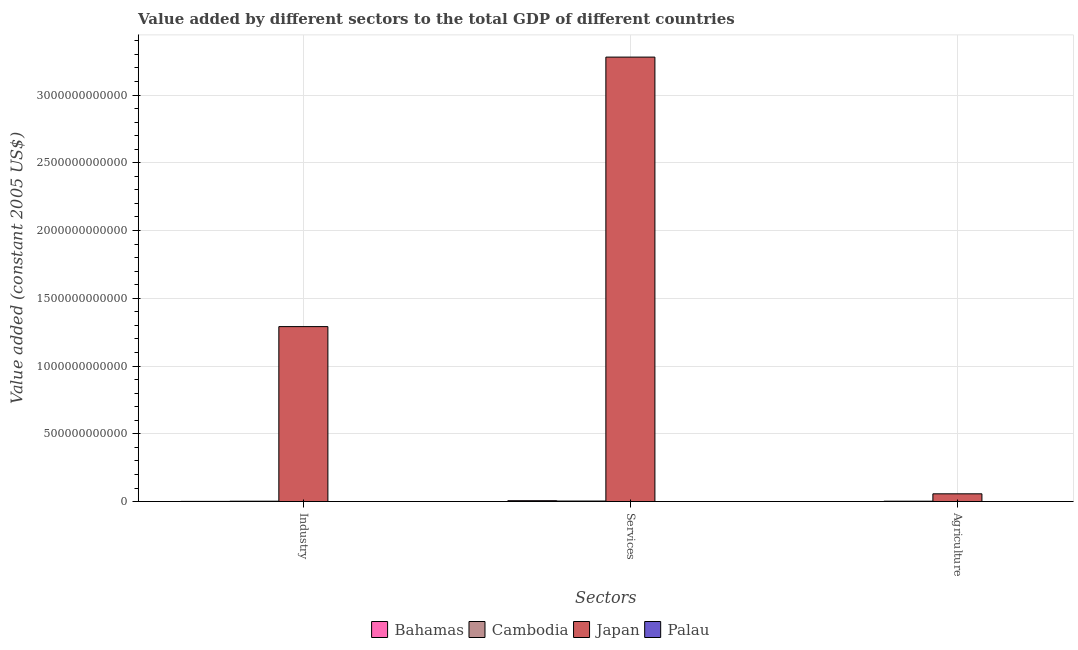How many groups of bars are there?
Keep it short and to the point. 3. Are the number of bars per tick equal to the number of legend labels?
Provide a succinct answer. Yes. Are the number of bars on each tick of the X-axis equal?
Give a very brief answer. Yes. What is the label of the 2nd group of bars from the left?
Your answer should be very brief. Services. What is the value added by agricultural sector in Palau?
Give a very brief answer. 7.39e+06. Across all countries, what is the maximum value added by industrial sector?
Your answer should be compact. 1.29e+12. Across all countries, what is the minimum value added by agricultural sector?
Offer a terse response. 7.39e+06. In which country was the value added by agricultural sector maximum?
Keep it short and to the point. Japan. In which country was the value added by industrial sector minimum?
Make the answer very short. Palau. What is the total value added by agricultural sector in the graph?
Your answer should be very brief. 6.00e+1. What is the difference between the value added by agricultural sector in Cambodia and that in Palau?
Provide a succinct answer. 2.66e+09. What is the difference between the value added by services in Palau and the value added by agricultural sector in Cambodia?
Your answer should be very brief. -2.52e+09. What is the average value added by industrial sector per country?
Ensure brevity in your answer.  3.24e+11. What is the difference between the value added by agricultural sector and value added by industrial sector in Japan?
Offer a very short reply. -1.23e+12. What is the ratio of the value added by agricultural sector in Japan to that in Cambodia?
Offer a terse response. 21.42. Is the difference between the value added by services in Japan and Cambodia greater than the difference between the value added by agricultural sector in Japan and Cambodia?
Your response must be concise. Yes. What is the difference between the highest and the second highest value added by agricultural sector?
Offer a terse response. 5.45e+1. What is the difference between the highest and the lowest value added by services?
Your answer should be compact. 3.28e+12. What does the 2nd bar from the left in Agriculture represents?
Provide a short and direct response. Cambodia. What does the 4th bar from the right in Agriculture represents?
Give a very brief answer. Bahamas. How many bars are there?
Your answer should be very brief. 12. How many countries are there in the graph?
Offer a terse response. 4. What is the difference between two consecutive major ticks on the Y-axis?
Offer a terse response. 5.00e+11. Does the graph contain any zero values?
Provide a short and direct response. No. Does the graph contain grids?
Your answer should be compact. Yes. How are the legend labels stacked?
Ensure brevity in your answer.  Horizontal. What is the title of the graph?
Offer a very short reply. Value added by different sectors to the total GDP of different countries. What is the label or title of the X-axis?
Offer a terse response. Sectors. What is the label or title of the Y-axis?
Ensure brevity in your answer.  Value added (constant 2005 US$). What is the Value added (constant 2005 US$) of Bahamas in Industry?
Keep it short and to the point. 1.32e+09. What is the Value added (constant 2005 US$) of Cambodia in Industry?
Provide a succinct answer. 2.70e+09. What is the Value added (constant 2005 US$) in Japan in Industry?
Ensure brevity in your answer.  1.29e+12. What is the Value added (constant 2005 US$) in Palau in Industry?
Your answer should be compact. 1.29e+07. What is the Value added (constant 2005 US$) in Bahamas in Services?
Offer a very short reply. 6.39e+09. What is the Value added (constant 2005 US$) of Cambodia in Services?
Provide a short and direct response. 3.90e+09. What is the Value added (constant 2005 US$) in Japan in Services?
Keep it short and to the point. 3.28e+12. What is the Value added (constant 2005 US$) in Palau in Services?
Make the answer very short. 1.47e+08. What is the Value added (constant 2005 US$) in Bahamas in Agriculture?
Your answer should be compact. 1.43e+08. What is the Value added (constant 2005 US$) of Cambodia in Agriculture?
Offer a very short reply. 2.67e+09. What is the Value added (constant 2005 US$) in Japan in Agriculture?
Give a very brief answer. 5.71e+1. What is the Value added (constant 2005 US$) in Palau in Agriculture?
Offer a very short reply. 7.39e+06. Across all Sectors, what is the maximum Value added (constant 2005 US$) in Bahamas?
Your response must be concise. 6.39e+09. Across all Sectors, what is the maximum Value added (constant 2005 US$) of Cambodia?
Offer a terse response. 3.90e+09. Across all Sectors, what is the maximum Value added (constant 2005 US$) in Japan?
Provide a succinct answer. 3.28e+12. Across all Sectors, what is the maximum Value added (constant 2005 US$) of Palau?
Your answer should be compact. 1.47e+08. Across all Sectors, what is the minimum Value added (constant 2005 US$) in Bahamas?
Make the answer very short. 1.43e+08. Across all Sectors, what is the minimum Value added (constant 2005 US$) in Cambodia?
Give a very brief answer. 2.67e+09. Across all Sectors, what is the minimum Value added (constant 2005 US$) in Japan?
Make the answer very short. 5.71e+1. Across all Sectors, what is the minimum Value added (constant 2005 US$) of Palau?
Your answer should be very brief. 7.39e+06. What is the total Value added (constant 2005 US$) of Bahamas in the graph?
Your response must be concise. 7.86e+09. What is the total Value added (constant 2005 US$) of Cambodia in the graph?
Offer a terse response. 9.27e+09. What is the total Value added (constant 2005 US$) of Japan in the graph?
Your answer should be very brief. 4.63e+12. What is the total Value added (constant 2005 US$) of Palau in the graph?
Provide a succinct answer. 1.68e+08. What is the difference between the Value added (constant 2005 US$) of Bahamas in Industry and that in Services?
Ensure brevity in your answer.  -5.07e+09. What is the difference between the Value added (constant 2005 US$) of Cambodia in Industry and that in Services?
Ensure brevity in your answer.  -1.20e+09. What is the difference between the Value added (constant 2005 US$) of Japan in Industry and that in Services?
Offer a very short reply. -1.99e+12. What is the difference between the Value added (constant 2005 US$) of Palau in Industry and that in Services?
Make the answer very short. -1.34e+08. What is the difference between the Value added (constant 2005 US$) of Bahamas in Industry and that in Agriculture?
Keep it short and to the point. 1.18e+09. What is the difference between the Value added (constant 2005 US$) of Cambodia in Industry and that in Agriculture?
Offer a very short reply. 3.20e+07. What is the difference between the Value added (constant 2005 US$) in Japan in Industry and that in Agriculture?
Keep it short and to the point. 1.23e+12. What is the difference between the Value added (constant 2005 US$) of Palau in Industry and that in Agriculture?
Give a very brief answer. 5.53e+06. What is the difference between the Value added (constant 2005 US$) in Bahamas in Services and that in Agriculture?
Keep it short and to the point. 6.25e+09. What is the difference between the Value added (constant 2005 US$) of Cambodia in Services and that in Agriculture?
Offer a terse response. 1.23e+09. What is the difference between the Value added (constant 2005 US$) of Japan in Services and that in Agriculture?
Your answer should be very brief. 3.22e+12. What is the difference between the Value added (constant 2005 US$) of Palau in Services and that in Agriculture?
Ensure brevity in your answer.  1.40e+08. What is the difference between the Value added (constant 2005 US$) in Bahamas in Industry and the Value added (constant 2005 US$) in Cambodia in Services?
Ensure brevity in your answer.  -2.58e+09. What is the difference between the Value added (constant 2005 US$) in Bahamas in Industry and the Value added (constant 2005 US$) in Japan in Services?
Your answer should be very brief. -3.28e+12. What is the difference between the Value added (constant 2005 US$) in Bahamas in Industry and the Value added (constant 2005 US$) in Palau in Services?
Offer a very short reply. 1.18e+09. What is the difference between the Value added (constant 2005 US$) of Cambodia in Industry and the Value added (constant 2005 US$) of Japan in Services?
Provide a succinct answer. -3.28e+12. What is the difference between the Value added (constant 2005 US$) in Cambodia in Industry and the Value added (constant 2005 US$) in Palau in Services?
Provide a succinct answer. 2.55e+09. What is the difference between the Value added (constant 2005 US$) of Japan in Industry and the Value added (constant 2005 US$) of Palau in Services?
Make the answer very short. 1.29e+12. What is the difference between the Value added (constant 2005 US$) in Bahamas in Industry and the Value added (constant 2005 US$) in Cambodia in Agriculture?
Offer a very short reply. -1.34e+09. What is the difference between the Value added (constant 2005 US$) of Bahamas in Industry and the Value added (constant 2005 US$) of Japan in Agriculture?
Make the answer very short. -5.58e+1. What is the difference between the Value added (constant 2005 US$) of Bahamas in Industry and the Value added (constant 2005 US$) of Palau in Agriculture?
Keep it short and to the point. 1.32e+09. What is the difference between the Value added (constant 2005 US$) in Cambodia in Industry and the Value added (constant 2005 US$) in Japan in Agriculture?
Provide a short and direct response. -5.44e+1. What is the difference between the Value added (constant 2005 US$) of Cambodia in Industry and the Value added (constant 2005 US$) of Palau in Agriculture?
Your answer should be very brief. 2.69e+09. What is the difference between the Value added (constant 2005 US$) in Japan in Industry and the Value added (constant 2005 US$) in Palau in Agriculture?
Ensure brevity in your answer.  1.29e+12. What is the difference between the Value added (constant 2005 US$) of Bahamas in Services and the Value added (constant 2005 US$) of Cambodia in Agriculture?
Your answer should be very brief. 3.73e+09. What is the difference between the Value added (constant 2005 US$) of Bahamas in Services and the Value added (constant 2005 US$) of Japan in Agriculture?
Ensure brevity in your answer.  -5.07e+1. What is the difference between the Value added (constant 2005 US$) of Bahamas in Services and the Value added (constant 2005 US$) of Palau in Agriculture?
Offer a terse response. 6.39e+09. What is the difference between the Value added (constant 2005 US$) of Cambodia in Services and the Value added (constant 2005 US$) of Japan in Agriculture?
Your answer should be very brief. -5.32e+1. What is the difference between the Value added (constant 2005 US$) of Cambodia in Services and the Value added (constant 2005 US$) of Palau in Agriculture?
Give a very brief answer. 3.89e+09. What is the difference between the Value added (constant 2005 US$) in Japan in Services and the Value added (constant 2005 US$) in Palau in Agriculture?
Your answer should be very brief. 3.28e+12. What is the average Value added (constant 2005 US$) of Bahamas per Sectors?
Provide a succinct answer. 2.62e+09. What is the average Value added (constant 2005 US$) in Cambodia per Sectors?
Provide a short and direct response. 3.09e+09. What is the average Value added (constant 2005 US$) of Japan per Sectors?
Ensure brevity in your answer.  1.54e+12. What is the average Value added (constant 2005 US$) in Palau per Sectors?
Your answer should be compact. 5.59e+07. What is the difference between the Value added (constant 2005 US$) in Bahamas and Value added (constant 2005 US$) in Cambodia in Industry?
Give a very brief answer. -1.37e+09. What is the difference between the Value added (constant 2005 US$) of Bahamas and Value added (constant 2005 US$) of Japan in Industry?
Provide a short and direct response. -1.29e+12. What is the difference between the Value added (constant 2005 US$) of Bahamas and Value added (constant 2005 US$) of Palau in Industry?
Ensure brevity in your answer.  1.31e+09. What is the difference between the Value added (constant 2005 US$) in Cambodia and Value added (constant 2005 US$) in Japan in Industry?
Ensure brevity in your answer.  -1.29e+12. What is the difference between the Value added (constant 2005 US$) in Cambodia and Value added (constant 2005 US$) in Palau in Industry?
Your response must be concise. 2.69e+09. What is the difference between the Value added (constant 2005 US$) of Japan and Value added (constant 2005 US$) of Palau in Industry?
Your response must be concise. 1.29e+12. What is the difference between the Value added (constant 2005 US$) of Bahamas and Value added (constant 2005 US$) of Cambodia in Services?
Offer a terse response. 2.49e+09. What is the difference between the Value added (constant 2005 US$) in Bahamas and Value added (constant 2005 US$) in Japan in Services?
Ensure brevity in your answer.  -3.27e+12. What is the difference between the Value added (constant 2005 US$) of Bahamas and Value added (constant 2005 US$) of Palau in Services?
Keep it short and to the point. 6.25e+09. What is the difference between the Value added (constant 2005 US$) of Cambodia and Value added (constant 2005 US$) of Japan in Services?
Make the answer very short. -3.28e+12. What is the difference between the Value added (constant 2005 US$) of Cambodia and Value added (constant 2005 US$) of Palau in Services?
Keep it short and to the point. 3.75e+09. What is the difference between the Value added (constant 2005 US$) in Japan and Value added (constant 2005 US$) in Palau in Services?
Your answer should be very brief. 3.28e+12. What is the difference between the Value added (constant 2005 US$) of Bahamas and Value added (constant 2005 US$) of Cambodia in Agriculture?
Your response must be concise. -2.52e+09. What is the difference between the Value added (constant 2005 US$) of Bahamas and Value added (constant 2005 US$) of Japan in Agriculture?
Make the answer very short. -5.70e+1. What is the difference between the Value added (constant 2005 US$) of Bahamas and Value added (constant 2005 US$) of Palau in Agriculture?
Offer a very short reply. 1.36e+08. What is the difference between the Value added (constant 2005 US$) of Cambodia and Value added (constant 2005 US$) of Japan in Agriculture?
Provide a short and direct response. -5.45e+1. What is the difference between the Value added (constant 2005 US$) of Cambodia and Value added (constant 2005 US$) of Palau in Agriculture?
Provide a succinct answer. 2.66e+09. What is the difference between the Value added (constant 2005 US$) in Japan and Value added (constant 2005 US$) in Palau in Agriculture?
Your answer should be very brief. 5.71e+1. What is the ratio of the Value added (constant 2005 US$) in Bahamas in Industry to that in Services?
Your answer should be compact. 0.21. What is the ratio of the Value added (constant 2005 US$) of Cambodia in Industry to that in Services?
Give a very brief answer. 0.69. What is the ratio of the Value added (constant 2005 US$) in Japan in Industry to that in Services?
Make the answer very short. 0.39. What is the ratio of the Value added (constant 2005 US$) in Palau in Industry to that in Services?
Provide a succinct answer. 0.09. What is the ratio of the Value added (constant 2005 US$) in Bahamas in Industry to that in Agriculture?
Make the answer very short. 9.27. What is the ratio of the Value added (constant 2005 US$) in Japan in Industry to that in Agriculture?
Make the answer very short. 22.6. What is the ratio of the Value added (constant 2005 US$) in Palau in Industry to that in Agriculture?
Provide a short and direct response. 1.75. What is the ratio of the Value added (constant 2005 US$) in Bahamas in Services to that in Agriculture?
Give a very brief answer. 44.73. What is the ratio of the Value added (constant 2005 US$) in Cambodia in Services to that in Agriculture?
Offer a very short reply. 1.46. What is the ratio of the Value added (constant 2005 US$) in Japan in Services to that in Agriculture?
Keep it short and to the point. 57.41. What is the ratio of the Value added (constant 2005 US$) in Palau in Services to that in Agriculture?
Keep it short and to the point. 19.94. What is the difference between the highest and the second highest Value added (constant 2005 US$) of Bahamas?
Keep it short and to the point. 5.07e+09. What is the difference between the highest and the second highest Value added (constant 2005 US$) of Cambodia?
Provide a succinct answer. 1.20e+09. What is the difference between the highest and the second highest Value added (constant 2005 US$) of Japan?
Give a very brief answer. 1.99e+12. What is the difference between the highest and the second highest Value added (constant 2005 US$) of Palau?
Provide a short and direct response. 1.34e+08. What is the difference between the highest and the lowest Value added (constant 2005 US$) in Bahamas?
Offer a very short reply. 6.25e+09. What is the difference between the highest and the lowest Value added (constant 2005 US$) of Cambodia?
Ensure brevity in your answer.  1.23e+09. What is the difference between the highest and the lowest Value added (constant 2005 US$) in Japan?
Offer a very short reply. 3.22e+12. What is the difference between the highest and the lowest Value added (constant 2005 US$) in Palau?
Provide a succinct answer. 1.40e+08. 